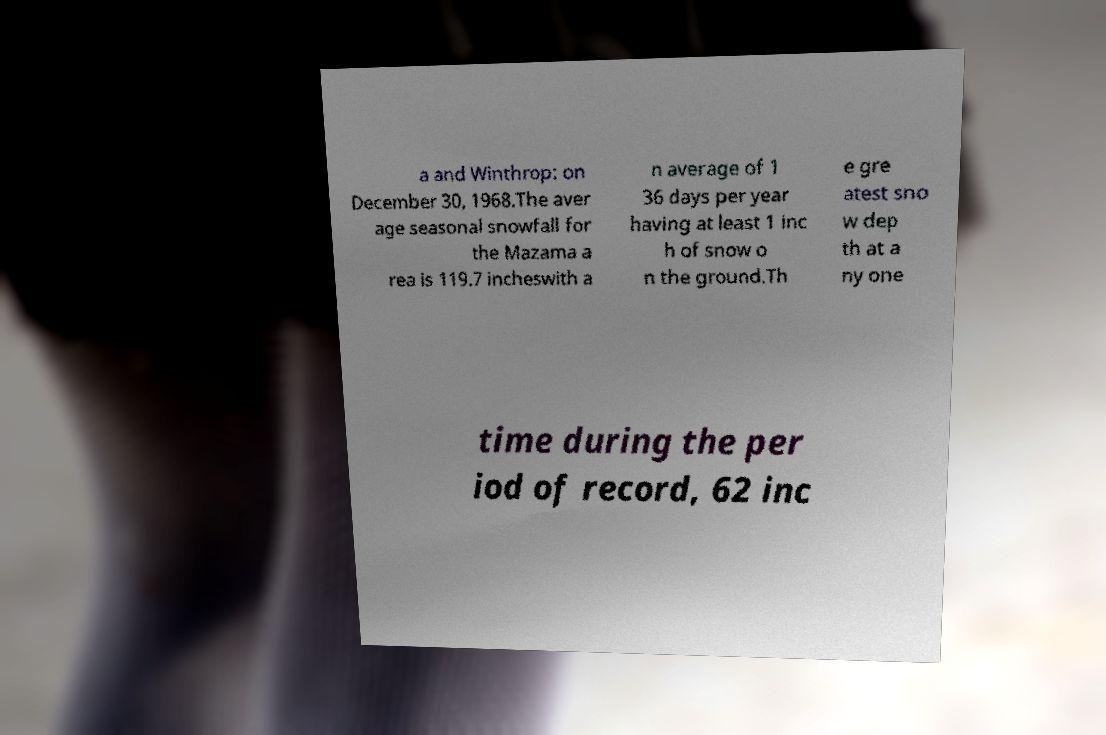I need the written content from this picture converted into text. Can you do that? a and Winthrop: on December 30, 1968.The aver age seasonal snowfall for the Mazama a rea is 119.7 incheswith a n average of 1 36 days per year having at least 1 inc h of snow o n the ground.Th e gre atest sno w dep th at a ny one time during the per iod of record, 62 inc 